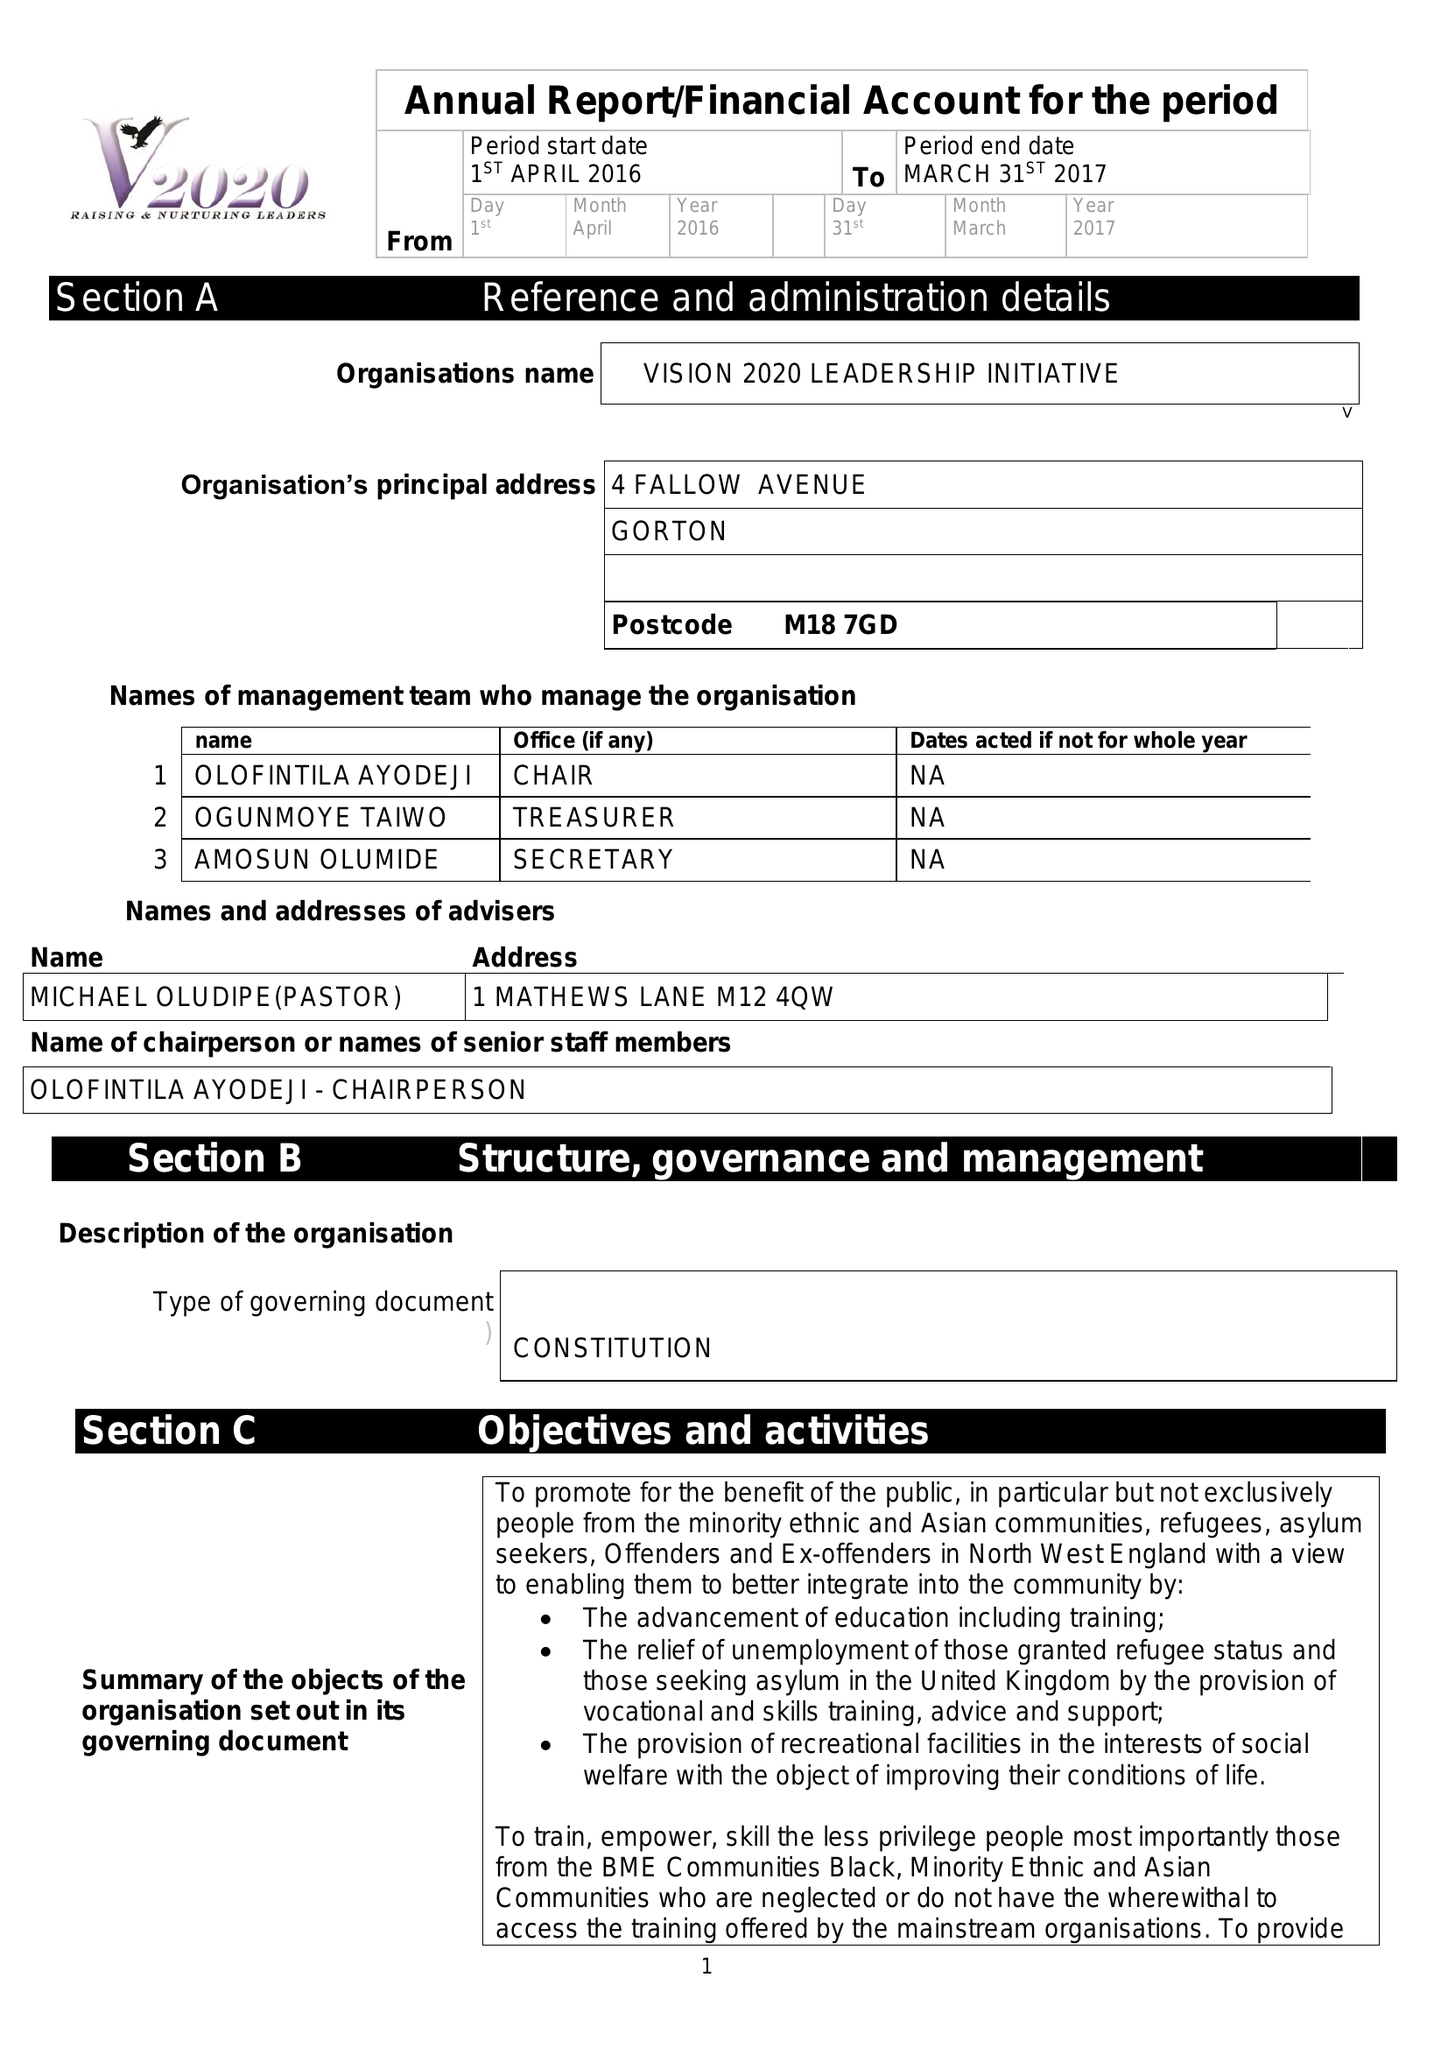What is the value for the charity_number?
Answer the question using a single word or phrase. 1142264 